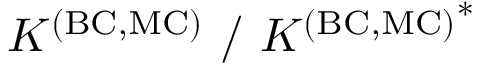Convert formula to latex. <formula><loc_0><loc_0><loc_500><loc_500>K ^ { ( B C , M C ) } / { K ^ { ( B C , M C ) } } ^ { * }</formula> 